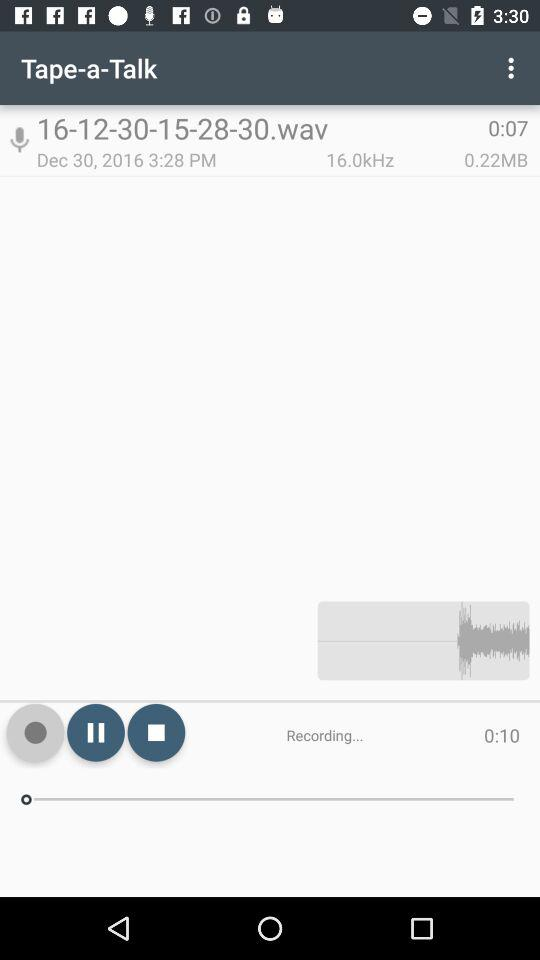How many MB are there for the recorded audio? There is 0.22 MB for the recorded audio. 